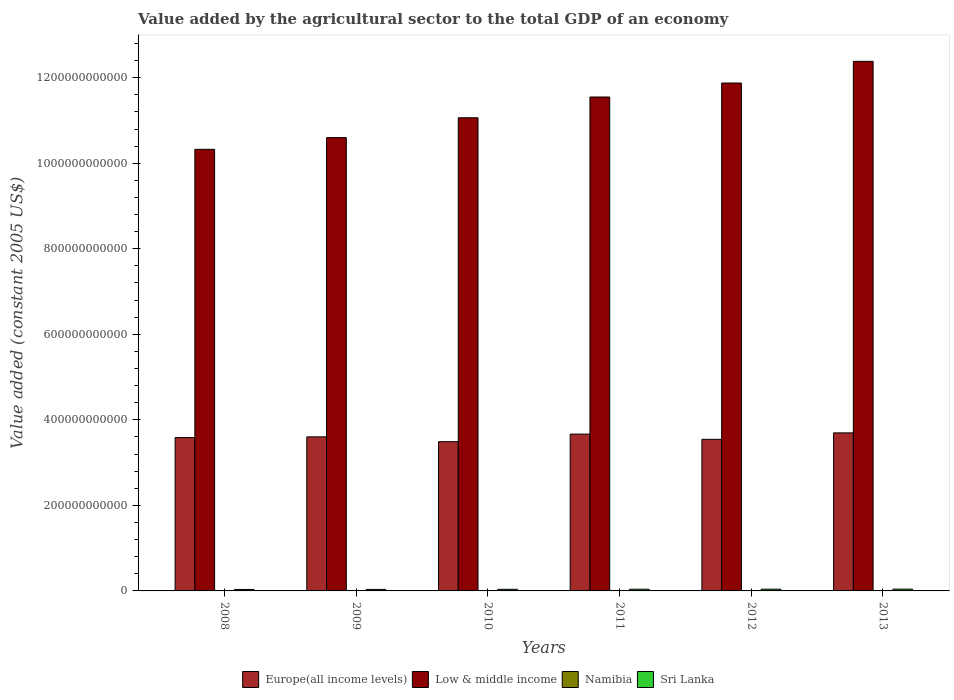Are the number of bars per tick equal to the number of legend labels?
Make the answer very short. Yes. How many bars are there on the 4th tick from the right?
Your answer should be very brief. 4. What is the label of the 1st group of bars from the left?
Offer a terse response. 2008. What is the value added by the agricultural sector in Sri Lanka in 2012?
Provide a short and direct response. 4.09e+09. Across all years, what is the maximum value added by the agricultural sector in Sri Lanka?
Ensure brevity in your answer.  4.23e+09. Across all years, what is the minimum value added by the agricultural sector in Sri Lanka?
Your answer should be compact. 3.41e+09. In which year was the value added by the agricultural sector in Namibia maximum?
Ensure brevity in your answer.  2012. In which year was the value added by the agricultural sector in Low & middle income minimum?
Keep it short and to the point. 2008. What is the total value added by the agricultural sector in Sri Lanka in the graph?
Your answer should be very brief. 2.30e+1. What is the difference between the value added by the agricultural sector in Low & middle income in 2011 and that in 2012?
Provide a short and direct response. -3.27e+1. What is the difference between the value added by the agricultural sector in Low & middle income in 2008 and the value added by the agricultural sector in Sri Lanka in 2012?
Your answer should be compact. 1.03e+12. What is the average value added by the agricultural sector in Namibia per year?
Your response must be concise. 6.26e+08. In the year 2009, what is the difference between the value added by the agricultural sector in Low & middle income and value added by the agricultural sector in Sri Lanka?
Provide a short and direct response. 1.06e+12. What is the ratio of the value added by the agricultural sector in Namibia in 2011 to that in 2013?
Provide a short and direct response. 1.11. Is the value added by the agricultural sector in Low & middle income in 2008 less than that in 2010?
Your response must be concise. Yes. What is the difference between the highest and the second highest value added by the agricultural sector in Namibia?
Your response must be concise. 4.06e+06. What is the difference between the highest and the lowest value added by the agricultural sector in Sri Lanka?
Ensure brevity in your answer.  8.16e+08. Is the sum of the value added by the agricultural sector in Europe(all income levels) in 2009 and 2013 greater than the maximum value added by the agricultural sector in Namibia across all years?
Ensure brevity in your answer.  Yes. Is it the case that in every year, the sum of the value added by the agricultural sector in Sri Lanka and value added by the agricultural sector in Namibia is greater than the sum of value added by the agricultural sector in Europe(all income levels) and value added by the agricultural sector in Low & middle income?
Make the answer very short. No. What does the 4th bar from the left in 2008 represents?
Your response must be concise. Sri Lanka. Is it the case that in every year, the sum of the value added by the agricultural sector in Sri Lanka and value added by the agricultural sector in Low & middle income is greater than the value added by the agricultural sector in Namibia?
Your answer should be compact. Yes. How many bars are there?
Offer a terse response. 24. How many years are there in the graph?
Offer a terse response. 6. What is the difference between two consecutive major ticks on the Y-axis?
Keep it short and to the point. 2.00e+11. Are the values on the major ticks of Y-axis written in scientific E-notation?
Your answer should be compact. No. Does the graph contain any zero values?
Keep it short and to the point. No. Does the graph contain grids?
Make the answer very short. No. How are the legend labels stacked?
Give a very brief answer. Horizontal. What is the title of the graph?
Provide a short and direct response. Value added by the agricultural sector to the total GDP of an economy. Does "Kazakhstan" appear as one of the legend labels in the graph?
Your answer should be compact. No. What is the label or title of the X-axis?
Ensure brevity in your answer.  Years. What is the label or title of the Y-axis?
Provide a succinct answer. Value added (constant 2005 US$). What is the Value added (constant 2005 US$) in Europe(all income levels) in 2008?
Give a very brief answer. 3.59e+11. What is the Value added (constant 2005 US$) of Low & middle income in 2008?
Make the answer very short. 1.03e+12. What is the Value added (constant 2005 US$) of Namibia in 2008?
Make the answer very short. 5.39e+08. What is the Value added (constant 2005 US$) of Sri Lanka in 2008?
Your response must be concise. 3.41e+09. What is the Value added (constant 2005 US$) of Europe(all income levels) in 2009?
Offer a very short reply. 3.60e+11. What is the Value added (constant 2005 US$) of Low & middle income in 2009?
Make the answer very short. 1.06e+12. What is the Value added (constant 2005 US$) of Namibia in 2009?
Your response must be concise. 6.35e+08. What is the Value added (constant 2005 US$) in Sri Lanka in 2009?
Keep it short and to the point. 3.52e+09. What is the Value added (constant 2005 US$) of Europe(all income levels) in 2010?
Keep it short and to the point. 3.49e+11. What is the Value added (constant 2005 US$) in Low & middle income in 2010?
Ensure brevity in your answer.  1.11e+12. What is the Value added (constant 2005 US$) in Namibia in 2010?
Offer a terse response. 6.65e+08. What is the Value added (constant 2005 US$) of Sri Lanka in 2010?
Provide a short and direct response. 3.76e+09. What is the Value added (constant 2005 US$) of Europe(all income levels) in 2011?
Offer a very short reply. 3.67e+11. What is the Value added (constant 2005 US$) of Low & middle income in 2011?
Your response must be concise. 1.15e+12. What is the Value added (constant 2005 US$) of Namibia in 2011?
Give a very brief answer. 6.57e+08. What is the Value added (constant 2005 US$) in Sri Lanka in 2011?
Provide a succinct answer. 3.94e+09. What is the Value added (constant 2005 US$) in Europe(all income levels) in 2012?
Offer a very short reply. 3.54e+11. What is the Value added (constant 2005 US$) in Low & middle income in 2012?
Offer a very short reply. 1.19e+12. What is the Value added (constant 2005 US$) in Namibia in 2012?
Ensure brevity in your answer.  6.69e+08. What is the Value added (constant 2005 US$) in Sri Lanka in 2012?
Keep it short and to the point. 4.09e+09. What is the Value added (constant 2005 US$) in Europe(all income levels) in 2013?
Your response must be concise. 3.70e+11. What is the Value added (constant 2005 US$) in Low & middle income in 2013?
Your response must be concise. 1.24e+12. What is the Value added (constant 2005 US$) in Namibia in 2013?
Offer a very short reply. 5.93e+08. What is the Value added (constant 2005 US$) of Sri Lanka in 2013?
Offer a very short reply. 4.23e+09. Across all years, what is the maximum Value added (constant 2005 US$) in Europe(all income levels)?
Keep it short and to the point. 3.70e+11. Across all years, what is the maximum Value added (constant 2005 US$) in Low & middle income?
Your answer should be very brief. 1.24e+12. Across all years, what is the maximum Value added (constant 2005 US$) in Namibia?
Provide a short and direct response. 6.69e+08. Across all years, what is the maximum Value added (constant 2005 US$) of Sri Lanka?
Your response must be concise. 4.23e+09. Across all years, what is the minimum Value added (constant 2005 US$) in Europe(all income levels)?
Provide a succinct answer. 3.49e+11. Across all years, what is the minimum Value added (constant 2005 US$) of Low & middle income?
Keep it short and to the point. 1.03e+12. Across all years, what is the minimum Value added (constant 2005 US$) in Namibia?
Your response must be concise. 5.39e+08. Across all years, what is the minimum Value added (constant 2005 US$) in Sri Lanka?
Provide a short and direct response. 3.41e+09. What is the total Value added (constant 2005 US$) in Europe(all income levels) in the graph?
Make the answer very short. 2.16e+12. What is the total Value added (constant 2005 US$) in Low & middle income in the graph?
Offer a very short reply. 6.78e+12. What is the total Value added (constant 2005 US$) of Namibia in the graph?
Your answer should be compact. 3.76e+09. What is the total Value added (constant 2005 US$) in Sri Lanka in the graph?
Give a very brief answer. 2.30e+1. What is the difference between the Value added (constant 2005 US$) of Europe(all income levels) in 2008 and that in 2009?
Make the answer very short. -1.71e+09. What is the difference between the Value added (constant 2005 US$) in Low & middle income in 2008 and that in 2009?
Provide a short and direct response. -2.73e+1. What is the difference between the Value added (constant 2005 US$) in Namibia in 2008 and that in 2009?
Keep it short and to the point. -9.55e+07. What is the difference between the Value added (constant 2005 US$) of Sri Lanka in 2008 and that in 2009?
Ensure brevity in your answer.  -1.10e+08. What is the difference between the Value added (constant 2005 US$) in Europe(all income levels) in 2008 and that in 2010?
Offer a very short reply. 9.54e+09. What is the difference between the Value added (constant 2005 US$) in Low & middle income in 2008 and that in 2010?
Ensure brevity in your answer.  -7.38e+1. What is the difference between the Value added (constant 2005 US$) in Namibia in 2008 and that in 2010?
Offer a very short reply. -1.26e+08. What is the difference between the Value added (constant 2005 US$) in Sri Lanka in 2008 and that in 2010?
Offer a terse response. -3.54e+08. What is the difference between the Value added (constant 2005 US$) of Europe(all income levels) in 2008 and that in 2011?
Offer a very short reply. -8.11e+09. What is the difference between the Value added (constant 2005 US$) in Low & middle income in 2008 and that in 2011?
Offer a very short reply. -1.22e+11. What is the difference between the Value added (constant 2005 US$) in Namibia in 2008 and that in 2011?
Offer a terse response. -1.17e+08. What is the difference between the Value added (constant 2005 US$) of Sri Lanka in 2008 and that in 2011?
Provide a succinct answer. -5.27e+08. What is the difference between the Value added (constant 2005 US$) of Europe(all income levels) in 2008 and that in 2012?
Your answer should be very brief. 4.11e+09. What is the difference between the Value added (constant 2005 US$) in Low & middle income in 2008 and that in 2012?
Offer a terse response. -1.55e+11. What is the difference between the Value added (constant 2005 US$) of Namibia in 2008 and that in 2012?
Provide a succinct answer. -1.30e+08. What is the difference between the Value added (constant 2005 US$) of Sri Lanka in 2008 and that in 2012?
Your response must be concise. -6.83e+08. What is the difference between the Value added (constant 2005 US$) in Europe(all income levels) in 2008 and that in 2013?
Ensure brevity in your answer.  -1.10e+1. What is the difference between the Value added (constant 2005 US$) of Low & middle income in 2008 and that in 2013?
Ensure brevity in your answer.  -2.06e+11. What is the difference between the Value added (constant 2005 US$) of Namibia in 2008 and that in 2013?
Provide a short and direct response. -5.40e+07. What is the difference between the Value added (constant 2005 US$) of Sri Lanka in 2008 and that in 2013?
Your response must be concise. -8.16e+08. What is the difference between the Value added (constant 2005 US$) in Europe(all income levels) in 2009 and that in 2010?
Offer a very short reply. 1.12e+1. What is the difference between the Value added (constant 2005 US$) in Low & middle income in 2009 and that in 2010?
Keep it short and to the point. -4.64e+1. What is the difference between the Value added (constant 2005 US$) in Namibia in 2009 and that in 2010?
Provide a succinct answer. -3.08e+07. What is the difference between the Value added (constant 2005 US$) of Sri Lanka in 2009 and that in 2010?
Make the answer very short. -2.45e+08. What is the difference between the Value added (constant 2005 US$) of Europe(all income levels) in 2009 and that in 2011?
Ensure brevity in your answer.  -6.40e+09. What is the difference between the Value added (constant 2005 US$) in Low & middle income in 2009 and that in 2011?
Your answer should be very brief. -9.50e+1. What is the difference between the Value added (constant 2005 US$) in Namibia in 2009 and that in 2011?
Keep it short and to the point. -2.20e+07. What is the difference between the Value added (constant 2005 US$) of Sri Lanka in 2009 and that in 2011?
Offer a very short reply. -4.18e+08. What is the difference between the Value added (constant 2005 US$) of Europe(all income levels) in 2009 and that in 2012?
Your response must be concise. 5.82e+09. What is the difference between the Value added (constant 2005 US$) in Low & middle income in 2009 and that in 2012?
Provide a succinct answer. -1.28e+11. What is the difference between the Value added (constant 2005 US$) in Namibia in 2009 and that in 2012?
Make the answer very short. -3.49e+07. What is the difference between the Value added (constant 2005 US$) in Sri Lanka in 2009 and that in 2012?
Your answer should be compact. -5.73e+08. What is the difference between the Value added (constant 2005 US$) of Europe(all income levels) in 2009 and that in 2013?
Provide a short and direct response. -9.27e+09. What is the difference between the Value added (constant 2005 US$) in Low & middle income in 2009 and that in 2013?
Provide a succinct answer. -1.78e+11. What is the difference between the Value added (constant 2005 US$) of Namibia in 2009 and that in 2013?
Provide a short and direct response. 4.15e+07. What is the difference between the Value added (constant 2005 US$) in Sri Lanka in 2009 and that in 2013?
Your answer should be very brief. -7.06e+08. What is the difference between the Value added (constant 2005 US$) in Europe(all income levels) in 2010 and that in 2011?
Ensure brevity in your answer.  -1.77e+1. What is the difference between the Value added (constant 2005 US$) in Low & middle income in 2010 and that in 2011?
Your answer should be compact. -4.86e+1. What is the difference between the Value added (constant 2005 US$) in Namibia in 2010 and that in 2011?
Your answer should be compact. 8.85e+06. What is the difference between the Value added (constant 2005 US$) of Sri Lanka in 2010 and that in 2011?
Give a very brief answer. -1.73e+08. What is the difference between the Value added (constant 2005 US$) of Europe(all income levels) in 2010 and that in 2012?
Your answer should be very brief. -5.43e+09. What is the difference between the Value added (constant 2005 US$) in Low & middle income in 2010 and that in 2012?
Offer a very short reply. -8.13e+1. What is the difference between the Value added (constant 2005 US$) of Namibia in 2010 and that in 2012?
Keep it short and to the point. -4.06e+06. What is the difference between the Value added (constant 2005 US$) in Sri Lanka in 2010 and that in 2012?
Keep it short and to the point. -3.28e+08. What is the difference between the Value added (constant 2005 US$) in Europe(all income levels) in 2010 and that in 2013?
Give a very brief answer. -2.05e+1. What is the difference between the Value added (constant 2005 US$) of Low & middle income in 2010 and that in 2013?
Provide a succinct answer. -1.32e+11. What is the difference between the Value added (constant 2005 US$) of Namibia in 2010 and that in 2013?
Offer a very short reply. 7.23e+07. What is the difference between the Value added (constant 2005 US$) of Sri Lanka in 2010 and that in 2013?
Your answer should be compact. -4.61e+08. What is the difference between the Value added (constant 2005 US$) in Europe(all income levels) in 2011 and that in 2012?
Offer a terse response. 1.22e+1. What is the difference between the Value added (constant 2005 US$) in Low & middle income in 2011 and that in 2012?
Provide a succinct answer. -3.27e+1. What is the difference between the Value added (constant 2005 US$) in Namibia in 2011 and that in 2012?
Provide a short and direct response. -1.29e+07. What is the difference between the Value added (constant 2005 US$) in Sri Lanka in 2011 and that in 2012?
Provide a short and direct response. -1.55e+08. What is the difference between the Value added (constant 2005 US$) of Europe(all income levels) in 2011 and that in 2013?
Provide a succinct answer. -2.87e+09. What is the difference between the Value added (constant 2005 US$) of Low & middle income in 2011 and that in 2013?
Offer a terse response. -8.34e+1. What is the difference between the Value added (constant 2005 US$) of Namibia in 2011 and that in 2013?
Ensure brevity in your answer.  6.34e+07. What is the difference between the Value added (constant 2005 US$) in Sri Lanka in 2011 and that in 2013?
Your response must be concise. -2.88e+08. What is the difference between the Value added (constant 2005 US$) in Europe(all income levels) in 2012 and that in 2013?
Keep it short and to the point. -1.51e+1. What is the difference between the Value added (constant 2005 US$) of Low & middle income in 2012 and that in 2013?
Your answer should be very brief. -5.07e+1. What is the difference between the Value added (constant 2005 US$) of Namibia in 2012 and that in 2013?
Offer a terse response. 7.63e+07. What is the difference between the Value added (constant 2005 US$) in Sri Lanka in 2012 and that in 2013?
Provide a succinct answer. -1.33e+08. What is the difference between the Value added (constant 2005 US$) in Europe(all income levels) in 2008 and the Value added (constant 2005 US$) in Low & middle income in 2009?
Ensure brevity in your answer.  -7.01e+11. What is the difference between the Value added (constant 2005 US$) of Europe(all income levels) in 2008 and the Value added (constant 2005 US$) of Namibia in 2009?
Make the answer very short. 3.58e+11. What is the difference between the Value added (constant 2005 US$) of Europe(all income levels) in 2008 and the Value added (constant 2005 US$) of Sri Lanka in 2009?
Give a very brief answer. 3.55e+11. What is the difference between the Value added (constant 2005 US$) of Low & middle income in 2008 and the Value added (constant 2005 US$) of Namibia in 2009?
Offer a terse response. 1.03e+12. What is the difference between the Value added (constant 2005 US$) of Low & middle income in 2008 and the Value added (constant 2005 US$) of Sri Lanka in 2009?
Offer a terse response. 1.03e+12. What is the difference between the Value added (constant 2005 US$) in Namibia in 2008 and the Value added (constant 2005 US$) in Sri Lanka in 2009?
Keep it short and to the point. -2.98e+09. What is the difference between the Value added (constant 2005 US$) of Europe(all income levels) in 2008 and the Value added (constant 2005 US$) of Low & middle income in 2010?
Offer a very short reply. -7.48e+11. What is the difference between the Value added (constant 2005 US$) in Europe(all income levels) in 2008 and the Value added (constant 2005 US$) in Namibia in 2010?
Keep it short and to the point. 3.58e+11. What is the difference between the Value added (constant 2005 US$) of Europe(all income levels) in 2008 and the Value added (constant 2005 US$) of Sri Lanka in 2010?
Your answer should be very brief. 3.55e+11. What is the difference between the Value added (constant 2005 US$) in Low & middle income in 2008 and the Value added (constant 2005 US$) in Namibia in 2010?
Offer a terse response. 1.03e+12. What is the difference between the Value added (constant 2005 US$) of Low & middle income in 2008 and the Value added (constant 2005 US$) of Sri Lanka in 2010?
Your answer should be very brief. 1.03e+12. What is the difference between the Value added (constant 2005 US$) of Namibia in 2008 and the Value added (constant 2005 US$) of Sri Lanka in 2010?
Your response must be concise. -3.23e+09. What is the difference between the Value added (constant 2005 US$) of Europe(all income levels) in 2008 and the Value added (constant 2005 US$) of Low & middle income in 2011?
Offer a terse response. -7.96e+11. What is the difference between the Value added (constant 2005 US$) in Europe(all income levels) in 2008 and the Value added (constant 2005 US$) in Namibia in 2011?
Provide a short and direct response. 3.58e+11. What is the difference between the Value added (constant 2005 US$) in Europe(all income levels) in 2008 and the Value added (constant 2005 US$) in Sri Lanka in 2011?
Offer a very short reply. 3.55e+11. What is the difference between the Value added (constant 2005 US$) in Low & middle income in 2008 and the Value added (constant 2005 US$) in Namibia in 2011?
Keep it short and to the point. 1.03e+12. What is the difference between the Value added (constant 2005 US$) in Low & middle income in 2008 and the Value added (constant 2005 US$) in Sri Lanka in 2011?
Keep it short and to the point. 1.03e+12. What is the difference between the Value added (constant 2005 US$) of Namibia in 2008 and the Value added (constant 2005 US$) of Sri Lanka in 2011?
Give a very brief answer. -3.40e+09. What is the difference between the Value added (constant 2005 US$) in Europe(all income levels) in 2008 and the Value added (constant 2005 US$) in Low & middle income in 2012?
Offer a very short reply. -8.29e+11. What is the difference between the Value added (constant 2005 US$) in Europe(all income levels) in 2008 and the Value added (constant 2005 US$) in Namibia in 2012?
Your answer should be very brief. 3.58e+11. What is the difference between the Value added (constant 2005 US$) in Europe(all income levels) in 2008 and the Value added (constant 2005 US$) in Sri Lanka in 2012?
Keep it short and to the point. 3.54e+11. What is the difference between the Value added (constant 2005 US$) in Low & middle income in 2008 and the Value added (constant 2005 US$) in Namibia in 2012?
Ensure brevity in your answer.  1.03e+12. What is the difference between the Value added (constant 2005 US$) of Low & middle income in 2008 and the Value added (constant 2005 US$) of Sri Lanka in 2012?
Your answer should be very brief. 1.03e+12. What is the difference between the Value added (constant 2005 US$) of Namibia in 2008 and the Value added (constant 2005 US$) of Sri Lanka in 2012?
Offer a terse response. -3.55e+09. What is the difference between the Value added (constant 2005 US$) of Europe(all income levels) in 2008 and the Value added (constant 2005 US$) of Low & middle income in 2013?
Provide a succinct answer. -8.80e+11. What is the difference between the Value added (constant 2005 US$) in Europe(all income levels) in 2008 and the Value added (constant 2005 US$) in Namibia in 2013?
Provide a succinct answer. 3.58e+11. What is the difference between the Value added (constant 2005 US$) in Europe(all income levels) in 2008 and the Value added (constant 2005 US$) in Sri Lanka in 2013?
Provide a short and direct response. 3.54e+11. What is the difference between the Value added (constant 2005 US$) in Low & middle income in 2008 and the Value added (constant 2005 US$) in Namibia in 2013?
Keep it short and to the point. 1.03e+12. What is the difference between the Value added (constant 2005 US$) in Low & middle income in 2008 and the Value added (constant 2005 US$) in Sri Lanka in 2013?
Your response must be concise. 1.03e+12. What is the difference between the Value added (constant 2005 US$) in Namibia in 2008 and the Value added (constant 2005 US$) in Sri Lanka in 2013?
Make the answer very short. -3.69e+09. What is the difference between the Value added (constant 2005 US$) in Europe(all income levels) in 2009 and the Value added (constant 2005 US$) in Low & middle income in 2010?
Your answer should be compact. -7.46e+11. What is the difference between the Value added (constant 2005 US$) of Europe(all income levels) in 2009 and the Value added (constant 2005 US$) of Namibia in 2010?
Ensure brevity in your answer.  3.60e+11. What is the difference between the Value added (constant 2005 US$) of Europe(all income levels) in 2009 and the Value added (constant 2005 US$) of Sri Lanka in 2010?
Your response must be concise. 3.56e+11. What is the difference between the Value added (constant 2005 US$) in Low & middle income in 2009 and the Value added (constant 2005 US$) in Namibia in 2010?
Provide a succinct answer. 1.06e+12. What is the difference between the Value added (constant 2005 US$) of Low & middle income in 2009 and the Value added (constant 2005 US$) of Sri Lanka in 2010?
Your answer should be very brief. 1.06e+12. What is the difference between the Value added (constant 2005 US$) in Namibia in 2009 and the Value added (constant 2005 US$) in Sri Lanka in 2010?
Your answer should be very brief. -3.13e+09. What is the difference between the Value added (constant 2005 US$) of Europe(all income levels) in 2009 and the Value added (constant 2005 US$) of Low & middle income in 2011?
Your answer should be very brief. -7.95e+11. What is the difference between the Value added (constant 2005 US$) in Europe(all income levels) in 2009 and the Value added (constant 2005 US$) in Namibia in 2011?
Your answer should be very brief. 3.60e+11. What is the difference between the Value added (constant 2005 US$) in Europe(all income levels) in 2009 and the Value added (constant 2005 US$) in Sri Lanka in 2011?
Ensure brevity in your answer.  3.56e+11. What is the difference between the Value added (constant 2005 US$) in Low & middle income in 2009 and the Value added (constant 2005 US$) in Namibia in 2011?
Offer a terse response. 1.06e+12. What is the difference between the Value added (constant 2005 US$) of Low & middle income in 2009 and the Value added (constant 2005 US$) of Sri Lanka in 2011?
Your answer should be very brief. 1.06e+12. What is the difference between the Value added (constant 2005 US$) in Namibia in 2009 and the Value added (constant 2005 US$) in Sri Lanka in 2011?
Your response must be concise. -3.30e+09. What is the difference between the Value added (constant 2005 US$) of Europe(all income levels) in 2009 and the Value added (constant 2005 US$) of Low & middle income in 2012?
Your response must be concise. -8.27e+11. What is the difference between the Value added (constant 2005 US$) of Europe(all income levels) in 2009 and the Value added (constant 2005 US$) of Namibia in 2012?
Your response must be concise. 3.60e+11. What is the difference between the Value added (constant 2005 US$) in Europe(all income levels) in 2009 and the Value added (constant 2005 US$) in Sri Lanka in 2012?
Give a very brief answer. 3.56e+11. What is the difference between the Value added (constant 2005 US$) of Low & middle income in 2009 and the Value added (constant 2005 US$) of Namibia in 2012?
Provide a succinct answer. 1.06e+12. What is the difference between the Value added (constant 2005 US$) in Low & middle income in 2009 and the Value added (constant 2005 US$) in Sri Lanka in 2012?
Provide a short and direct response. 1.06e+12. What is the difference between the Value added (constant 2005 US$) in Namibia in 2009 and the Value added (constant 2005 US$) in Sri Lanka in 2012?
Offer a terse response. -3.46e+09. What is the difference between the Value added (constant 2005 US$) of Europe(all income levels) in 2009 and the Value added (constant 2005 US$) of Low & middle income in 2013?
Ensure brevity in your answer.  -8.78e+11. What is the difference between the Value added (constant 2005 US$) of Europe(all income levels) in 2009 and the Value added (constant 2005 US$) of Namibia in 2013?
Give a very brief answer. 3.60e+11. What is the difference between the Value added (constant 2005 US$) of Europe(all income levels) in 2009 and the Value added (constant 2005 US$) of Sri Lanka in 2013?
Give a very brief answer. 3.56e+11. What is the difference between the Value added (constant 2005 US$) in Low & middle income in 2009 and the Value added (constant 2005 US$) in Namibia in 2013?
Make the answer very short. 1.06e+12. What is the difference between the Value added (constant 2005 US$) in Low & middle income in 2009 and the Value added (constant 2005 US$) in Sri Lanka in 2013?
Keep it short and to the point. 1.06e+12. What is the difference between the Value added (constant 2005 US$) of Namibia in 2009 and the Value added (constant 2005 US$) of Sri Lanka in 2013?
Offer a very short reply. -3.59e+09. What is the difference between the Value added (constant 2005 US$) of Europe(all income levels) in 2010 and the Value added (constant 2005 US$) of Low & middle income in 2011?
Your answer should be very brief. -8.06e+11. What is the difference between the Value added (constant 2005 US$) in Europe(all income levels) in 2010 and the Value added (constant 2005 US$) in Namibia in 2011?
Provide a succinct answer. 3.48e+11. What is the difference between the Value added (constant 2005 US$) of Europe(all income levels) in 2010 and the Value added (constant 2005 US$) of Sri Lanka in 2011?
Your response must be concise. 3.45e+11. What is the difference between the Value added (constant 2005 US$) of Low & middle income in 2010 and the Value added (constant 2005 US$) of Namibia in 2011?
Provide a succinct answer. 1.11e+12. What is the difference between the Value added (constant 2005 US$) of Low & middle income in 2010 and the Value added (constant 2005 US$) of Sri Lanka in 2011?
Make the answer very short. 1.10e+12. What is the difference between the Value added (constant 2005 US$) of Namibia in 2010 and the Value added (constant 2005 US$) of Sri Lanka in 2011?
Offer a very short reply. -3.27e+09. What is the difference between the Value added (constant 2005 US$) in Europe(all income levels) in 2010 and the Value added (constant 2005 US$) in Low & middle income in 2012?
Provide a succinct answer. -8.39e+11. What is the difference between the Value added (constant 2005 US$) of Europe(all income levels) in 2010 and the Value added (constant 2005 US$) of Namibia in 2012?
Give a very brief answer. 3.48e+11. What is the difference between the Value added (constant 2005 US$) in Europe(all income levels) in 2010 and the Value added (constant 2005 US$) in Sri Lanka in 2012?
Offer a terse response. 3.45e+11. What is the difference between the Value added (constant 2005 US$) in Low & middle income in 2010 and the Value added (constant 2005 US$) in Namibia in 2012?
Offer a terse response. 1.11e+12. What is the difference between the Value added (constant 2005 US$) in Low & middle income in 2010 and the Value added (constant 2005 US$) in Sri Lanka in 2012?
Provide a short and direct response. 1.10e+12. What is the difference between the Value added (constant 2005 US$) of Namibia in 2010 and the Value added (constant 2005 US$) of Sri Lanka in 2012?
Give a very brief answer. -3.43e+09. What is the difference between the Value added (constant 2005 US$) in Europe(all income levels) in 2010 and the Value added (constant 2005 US$) in Low & middle income in 2013?
Provide a succinct answer. -8.89e+11. What is the difference between the Value added (constant 2005 US$) of Europe(all income levels) in 2010 and the Value added (constant 2005 US$) of Namibia in 2013?
Make the answer very short. 3.48e+11. What is the difference between the Value added (constant 2005 US$) of Europe(all income levels) in 2010 and the Value added (constant 2005 US$) of Sri Lanka in 2013?
Your answer should be very brief. 3.45e+11. What is the difference between the Value added (constant 2005 US$) of Low & middle income in 2010 and the Value added (constant 2005 US$) of Namibia in 2013?
Keep it short and to the point. 1.11e+12. What is the difference between the Value added (constant 2005 US$) of Low & middle income in 2010 and the Value added (constant 2005 US$) of Sri Lanka in 2013?
Offer a very short reply. 1.10e+12. What is the difference between the Value added (constant 2005 US$) in Namibia in 2010 and the Value added (constant 2005 US$) in Sri Lanka in 2013?
Offer a terse response. -3.56e+09. What is the difference between the Value added (constant 2005 US$) of Europe(all income levels) in 2011 and the Value added (constant 2005 US$) of Low & middle income in 2012?
Provide a short and direct response. -8.21e+11. What is the difference between the Value added (constant 2005 US$) of Europe(all income levels) in 2011 and the Value added (constant 2005 US$) of Namibia in 2012?
Provide a succinct answer. 3.66e+11. What is the difference between the Value added (constant 2005 US$) of Europe(all income levels) in 2011 and the Value added (constant 2005 US$) of Sri Lanka in 2012?
Provide a short and direct response. 3.63e+11. What is the difference between the Value added (constant 2005 US$) of Low & middle income in 2011 and the Value added (constant 2005 US$) of Namibia in 2012?
Provide a short and direct response. 1.15e+12. What is the difference between the Value added (constant 2005 US$) of Low & middle income in 2011 and the Value added (constant 2005 US$) of Sri Lanka in 2012?
Keep it short and to the point. 1.15e+12. What is the difference between the Value added (constant 2005 US$) of Namibia in 2011 and the Value added (constant 2005 US$) of Sri Lanka in 2012?
Ensure brevity in your answer.  -3.44e+09. What is the difference between the Value added (constant 2005 US$) of Europe(all income levels) in 2011 and the Value added (constant 2005 US$) of Low & middle income in 2013?
Provide a succinct answer. -8.72e+11. What is the difference between the Value added (constant 2005 US$) in Europe(all income levels) in 2011 and the Value added (constant 2005 US$) in Namibia in 2013?
Your answer should be compact. 3.66e+11. What is the difference between the Value added (constant 2005 US$) of Europe(all income levels) in 2011 and the Value added (constant 2005 US$) of Sri Lanka in 2013?
Provide a succinct answer. 3.62e+11. What is the difference between the Value added (constant 2005 US$) of Low & middle income in 2011 and the Value added (constant 2005 US$) of Namibia in 2013?
Keep it short and to the point. 1.15e+12. What is the difference between the Value added (constant 2005 US$) in Low & middle income in 2011 and the Value added (constant 2005 US$) in Sri Lanka in 2013?
Your response must be concise. 1.15e+12. What is the difference between the Value added (constant 2005 US$) of Namibia in 2011 and the Value added (constant 2005 US$) of Sri Lanka in 2013?
Make the answer very short. -3.57e+09. What is the difference between the Value added (constant 2005 US$) in Europe(all income levels) in 2012 and the Value added (constant 2005 US$) in Low & middle income in 2013?
Provide a succinct answer. -8.84e+11. What is the difference between the Value added (constant 2005 US$) of Europe(all income levels) in 2012 and the Value added (constant 2005 US$) of Namibia in 2013?
Offer a very short reply. 3.54e+11. What is the difference between the Value added (constant 2005 US$) of Europe(all income levels) in 2012 and the Value added (constant 2005 US$) of Sri Lanka in 2013?
Ensure brevity in your answer.  3.50e+11. What is the difference between the Value added (constant 2005 US$) of Low & middle income in 2012 and the Value added (constant 2005 US$) of Namibia in 2013?
Your answer should be very brief. 1.19e+12. What is the difference between the Value added (constant 2005 US$) of Low & middle income in 2012 and the Value added (constant 2005 US$) of Sri Lanka in 2013?
Provide a succinct answer. 1.18e+12. What is the difference between the Value added (constant 2005 US$) of Namibia in 2012 and the Value added (constant 2005 US$) of Sri Lanka in 2013?
Give a very brief answer. -3.56e+09. What is the average Value added (constant 2005 US$) in Europe(all income levels) per year?
Your answer should be very brief. 3.60e+11. What is the average Value added (constant 2005 US$) of Low & middle income per year?
Offer a terse response. 1.13e+12. What is the average Value added (constant 2005 US$) of Namibia per year?
Ensure brevity in your answer.  6.26e+08. What is the average Value added (constant 2005 US$) of Sri Lanka per year?
Give a very brief answer. 3.83e+09. In the year 2008, what is the difference between the Value added (constant 2005 US$) of Europe(all income levels) and Value added (constant 2005 US$) of Low & middle income?
Ensure brevity in your answer.  -6.74e+11. In the year 2008, what is the difference between the Value added (constant 2005 US$) of Europe(all income levels) and Value added (constant 2005 US$) of Namibia?
Ensure brevity in your answer.  3.58e+11. In the year 2008, what is the difference between the Value added (constant 2005 US$) of Europe(all income levels) and Value added (constant 2005 US$) of Sri Lanka?
Make the answer very short. 3.55e+11. In the year 2008, what is the difference between the Value added (constant 2005 US$) in Low & middle income and Value added (constant 2005 US$) in Namibia?
Your answer should be very brief. 1.03e+12. In the year 2008, what is the difference between the Value added (constant 2005 US$) in Low & middle income and Value added (constant 2005 US$) in Sri Lanka?
Your answer should be very brief. 1.03e+12. In the year 2008, what is the difference between the Value added (constant 2005 US$) in Namibia and Value added (constant 2005 US$) in Sri Lanka?
Keep it short and to the point. -2.87e+09. In the year 2009, what is the difference between the Value added (constant 2005 US$) of Europe(all income levels) and Value added (constant 2005 US$) of Low & middle income?
Provide a succinct answer. -7.00e+11. In the year 2009, what is the difference between the Value added (constant 2005 US$) in Europe(all income levels) and Value added (constant 2005 US$) in Namibia?
Keep it short and to the point. 3.60e+11. In the year 2009, what is the difference between the Value added (constant 2005 US$) in Europe(all income levels) and Value added (constant 2005 US$) in Sri Lanka?
Ensure brevity in your answer.  3.57e+11. In the year 2009, what is the difference between the Value added (constant 2005 US$) of Low & middle income and Value added (constant 2005 US$) of Namibia?
Ensure brevity in your answer.  1.06e+12. In the year 2009, what is the difference between the Value added (constant 2005 US$) of Low & middle income and Value added (constant 2005 US$) of Sri Lanka?
Give a very brief answer. 1.06e+12. In the year 2009, what is the difference between the Value added (constant 2005 US$) of Namibia and Value added (constant 2005 US$) of Sri Lanka?
Your response must be concise. -2.89e+09. In the year 2010, what is the difference between the Value added (constant 2005 US$) in Europe(all income levels) and Value added (constant 2005 US$) in Low & middle income?
Ensure brevity in your answer.  -7.57e+11. In the year 2010, what is the difference between the Value added (constant 2005 US$) in Europe(all income levels) and Value added (constant 2005 US$) in Namibia?
Make the answer very short. 3.48e+11. In the year 2010, what is the difference between the Value added (constant 2005 US$) of Europe(all income levels) and Value added (constant 2005 US$) of Sri Lanka?
Your response must be concise. 3.45e+11. In the year 2010, what is the difference between the Value added (constant 2005 US$) in Low & middle income and Value added (constant 2005 US$) in Namibia?
Make the answer very short. 1.11e+12. In the year 2010, what is the difference between the Value added (constant 2005 US$) in Low & middle income and Value added (constant 2005 US$) in Sri Lanka?
Give a very brief answer. 1.10e+12. In the year 2010, what is the difference between the Value added (constant 2005 US$) in Namibia and Value added (constant 2005 US$) in Sri Lanka?
Provide a short and direct response. -3.10e+09. In the year 2011, what is the difference between the Value added (constant 2005 US$) in Europe(all income levels) and Value added (constant 2005 US$) in Low & middle income?
Offer a terse response. -7.88e+11. In the year 2011, what is the difference between the Value added (constant 2005 US$) in Europe(all income levels) and Value added (constant 2005 US$) in Namibia?
Provide a short and direct response. 3.66e+11. In the year 2011, what is the difference between the Value added (constant 2005 US$) in Europe(all income levels) and Value added (constant 2005 US$) in Sri Lanka?
Offer a very short reply. 3.63e+11. In the year 2011, what is the difference between the Value added (constant 2005 US$) in Low & middle income and Value added (constant 2005 US$) in Namibia?
Provide a succinct answer. 1.15e+12. In the year 2011, what is the difference between the Value added (constant 2005 US$) in Low & middle income and Value added (constant 2005 US$) in Sri Lanka?
Ensure brevity in your answer.  1.15e+12. In the year 2011, what is the difference between the Value added (constant 2005 US$) in Namibia and Value added (constant 2005 US$) in Sri Lanka?
Your answer should be compact. -3.28e+09. In the year 2012, what is the difference between the Value added (constant 2005 US$) in Europe(all income levels) and Value added (constant 2005 US$) in Low & middle income?
Offer a very short reply. -8.33e+11. In the year 2012, what is the difference between the Value added (constant 2005 US$) in Europe(all income levels) and Value added (constant 2005 US$) in Namibia?
Offer a terse response. 3.54e+11. In the year 2012, what is the difference between the Value added (constant 2005 US$) of Europe(all income levels) and Value added (constant 2005 US$) of Sri Lanka?
Keep it short and to the point. 3.50e+11. In the year 2012, what is the difference between the Value added (constant 2005 US$) in Low & middle income and Value added (constant 2005 US$) in Namibia?
Your answer should be compact. 1.19e+12. In the year 2012, what is the difference between the Value added (constant 2005 US$) of Low & middle income and Value added (constant 2005 US$) of Sri Lanka?
Make the answer very short. 1.18e+12. In the year 2012, what is the difference between the Value added (constant 2005 US$) in Namibia and Value added (constant 2005 US$) in Sri Lanka?
Make the answer very short. -3.42e+09. In the year 2013, what is the difference between the Value added (constant 2005 US$) of Europe(all income levels) and Value added (constant 2005 US$) of Low & middle income?
Give a very brief answer. -8.69e+11. In the year 2013, what is the difference between the Value added (constant 2005 US$) in Europe(all income levels) and Value added (constant 2005 US$) in Namibia?
Keep it short and to the point. 3.69e+11. In the year 2013, what is the difference between the Value added (constant 2005 US$) of Europe(all income levels) and Value added (constant 2005 US$) of Sri Lanka?
Keep it short and to the point. 3.65e+11. In the year 2013, what is the difference between the Value added (constant 2005 US$) in Low & middle income and Value added (constant 2005 US$) in Namibia?
Offer a very short reply. 1.24e+12. In the year 2013, what is the difference between the Value added (constant 2005 US$) of Low & middle income and Value added (constant 2005 US$) of Sri Lanka?
Offer a very short reply. 1.23e+12. In the year 2013, what is the difference between the Value added (constant 2005 US$) in Namibia and Value added (constant 2005 US$) in Sri Lanka?
Your response must be concise. -3.63e+09. What is the ratio of the Value added (constant 2005 US$) in Europe(all income levels) in 2008 to that in 2009?
Your answer should be compact. 1. What is the ratio of the Value added (constant 2005 US$) in Low & middle income in 2008 to that in 2009?
Offer a very short reply. 0.97. What is the ratio of the Value added (constant 2005 US$) of Namibia in 2008 to that in 2009?
Ensure brevity in your answer.  0.85. What is the ratio of the Value added (constant 2005 US$) in Sri Lanka in 2008 to that in 2009?
Your answer should be very brief. 0.97. What is the ratio of the Value added (constant 2005 US$) of Europe(all income levels) in 2008 to that in 2010?
Offer a terse response. 1.03. What is the ratio of the Value added (constant 2005 US$) in Low & middle income in 2008 to that in 2010?
Offer a very short reply. 0.93. What is the ratio of the Value added (constant 2005 US$) in Namibia in 2008 to that in 2010?
Offer a terse response. 0.81. What is the ratio of the Value added (constant 2005 US$) in Sri Lanka in 2008 to that in 2010?
Provide a succinct answer. 0.91. What is the ratio of the Value added (constant 2005 US$) in Europe(all income levels) in 2008 to that in 2011?
Provide a short and direct response. 0.98. What is the ratio of the Value added (constant 2005 US$) in Low & middle income in 2008 to that in 2011?
Offer a terse response. 0.89. What is the ratio of the Value added (constant 2005 US$) in Namibia in 2008 to that in 2011?
Your answer should be very brief. 0.82. What is the ratio of the Value added (constant 2005 US$) of Sri Lanka in 2008 to that in 2011?
Provide a short and direct response. 0.87. What is the ratio of the Value added (constant 2005 US$) of Europe(all income levels) in 2008 to that in 2012?
Ensure brevity in your answer.  1.01. What is the ratio of the Value added (constant 2005 US$) in Low & middle income in 2008 to that in 2012?
Keep it short and to the point. 0.87. What is the ratio of the Value added (constant 2005 US$) of Namibia in 2008 to that in 2012?
Your response must be concise. 0.81. What is the ratio of the Value added (constant 2005 US$) in Sri Lanka in 2008 to that in 2012?
Make the answer very short. 0.83. What is the ratio of the Value added (constant 2005 US$) of Europe(all income levels) in 2008 to that in 2013?
Keep it short and to the point. 0.97. What is the ratio of the Value added (constant 2005 US$) of Low & middle income in 2008 to that in 2013?
Offer a terse response. 0.83. What is the ratio of the Value added (constant 2005 US$) of Namibia in 2008 to that in 2013?
Make the answer very short. 0.91. What is the ratio of the Value added (constant 2005 US$) of Sri Lanka in 2008 to that in 2013?
Keep it short and to the point. 0.81. What is the ratio of the Value added (constant 2005 US$) of Europe(all income levels) in 2009 to that in 2010?
Your answer should be very brief. 1.03. What is the ratio of the Value added (constant 2005 US$) in Low & middle income in 2009 to that in 2010?
Offer a terse response. 0.96. What is the ratio of the Value added (constant 2005 US$) in Namibia in 2009 to that in 2010?
Your answer should be compact. 0.95. What is the ratio of the Value added (constant 2005 US$) of Sri Lanka in 2009 to that in 2010?
Make the answer very short. 0.94. What is the ratio of the Value added (constant 2005 US$) in Europe(all income levels) in 2009 to that in 2011?
Give a very brief answer. 0.98. What is the ratio of the Value added (constant 2005 US$) in Low & middle income in 2009 to that in 2011?
Your response must be concise. 0.92. What is the ratio of the Value added (constant 2005 US$) in Namibia in 2009 to that in 2011?
Your response must be concise. 0.97. What is the ratio of the Value added (constant 2005 US$) in Sri Lanka in 2009 to that in 2011?
Make the answer very short. 0.89. What is the ratio of the Value added (constant 2005 US$) in Europe(all income levels) in 2009 to that in 2012?
Make the answer very short. 1.02. What is the ratio of the Value added (constant 2005 US$) in Low & middle income in 2009 to that in 2012?
Provide a short and direct response. 0.89. What is the ratio of the Value added (constant 2005 US$) in Namibia in 2009 to that in 2012?
Provide a short and direct response. 0.95. What is the ratio of the Value added (constant 2005 US$) in Sri Lanka in 2009 to that in 2012?
Provide a succinct answer. 0.86. What is the ratio of the Value added (constant 2005 US$) in Europe(all income levels) in 2009 to that in 2013?
Ensure brevity in your answer.  0.97. What is the ratio of the Value added (constant 2005 US$) in Low & middle income in 2009 to that in 2013?
Your answer should be compact. 0.86. What is the ratio of the Value added (constant 2005 US$) in Namibia in 2009 to that in 2013?
Your answer should be compact. 1.07. What is the ratio of the Value added (constant 2005 US$) in Sri Lanka in 2009 to that in 2013?
Your answer should be compact. 0.83. What is the ratio of the Value added (constant 2005 US$) in Europe(all income levels) in 2010 to that in 2011?
Make the answer very short. 0.95. What is the ratio of the Value added (constant 2005 US$) of Low & middle income in 2010 to that in 2011?
Provide a succinct answer. 0.96. What is the ratio of the Value added (constant 2005 US$) in Namibia in 2010 to that in 2011?
Your answer should be very brief. 1.01. What is the ratio of the Value added (constant 2005 US$) in Sri Lanka in 2010 to that in 2011?
Provide a short and direct response. 0.96. What is the ratio of the Value added (constant 2005 US$) of Europe(all income levels) in 2010 to that in 2012?
Provide a succinct answer. 0.98. What is the ratio of the Value added (constant 2005 US$) in Low & middle income in 2010 to that in 2012?
Your response must be concise. 0.93. What is the ratio of the Value added (constant 2005 US$) in Namibia in 2010 to that in 2012?
Provide a short and direct response. 0.99. What is the ratio of the Value added (constant 2005 US$) in Sri Lanka in 2010 to that in 2012?
Your response must be concise. 0.92. What is the ratio of the Value added (constant 2005 US$) of Europe(all income levels) in 2010 to that in 2013?
Provide a succinct answer. 0.94. What is the ratio of the Value added (constant 2005 US$) of Low & middle income in 2010 to that in 2013?
Your response must be concise. 0.89. What is the ratio of the Value added (constant 2005 US$) in Namibia in 2010 to that in 2013?
Offer a very short reply. 1.12. What is the ratio of the Value added (constant 2005 US$) of Sri Lanka in 2010 to that in 2013?
Offer a very short reply. 0.89. What is the ratio of the Value added (constant 2005 US$) in Europe(all income levels) in 2011 to that in 2012?
Offer a very short reply. 1.03. What is the ratio of the Value added (constant 2005 US$) in Low & middle income in 2011 to that in 2012?
Ensure brevity in your answer.  0.97. What is the ratio of the Value added (constant 2005 US$) of Namibia in 2011 to that in 2012?
Ensure brevity in your answer.  0.98. What is the ratio of the Value added (constant 2005 US$) in Low & middle income in 2011 to that in 2013?
Offer a very short reply. 0.93. What is the ratio of the Value added (constant 2005 US$) of Namibia in 2011 to that in 2013?
Your answer should be compact. 1.11. What is the ratio of the Value added (constant 2005 US$) in Sri Lanka in 2011 to that in 2013?
Your answer should be compact. 0.93. What is the ratio of the Value added (constant 2005 US$) of Europe(all income levels) in 2012 to that in 2013?
Offer a terse response. 0.96. What is the ratio of the Value added (constant 2005 US$) of Low & middle income in 2012 to that in 2013?
Your answer should be compact. 0.96. What is the ratio of the Value added (constant 2005 US$) in Namibia in 2012 to that in 2013?
Offer a terse response. 1.13. What is the ratio of the Value added (constant 2005 US$) of Sri Lanka in 2012 to that in 2013?
Your answer should be very brief. 0.97. What is the difference between the highest and the second highest Value added (constant 2005 US$) of Europe(all income levels)?
Keep it short and to the point. 2.87e+09. What is the difference between the highest and the second highest Value added (constant 2005 US$) in Low & middle income?
Your answer should be very brief. 5.07e+1. What is the difference between the highest and the second highest Value added (constant 2005 US$) of Namibia?
Ensure brevity in your answer.  4.06e+06. What is the difference between the highest and the second highest Value added (constant 2005 US$) of Sri Lanka?
Your answer should be compact. 1.33e+08. What is the difference between the highest and the lowest Value added (constant 2005 US$) of Europe(all income levels)?
Your answer should be compact. 2.05e+1. What is the difference between the highest and the lowest Value added (constant 2005 US$) of Low & middle income?
Offer a terse response. 2.06e+11. What is the difference between the highest and the lowest Value added (constant 2005 US$) in Namibia?
Ensure brevity in your answer.  1.30e+08. What is the difference between the highest and the lowest Value added (constant 2005 US$) in Sri Lanka?
Your answer should be compact. 8.16e+08. 